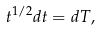Convert formula to latex. <formula><loc_0><loc_0><loc_500><loc_500>t ^ { 1 / 2 } d t = d T ,</formula> 